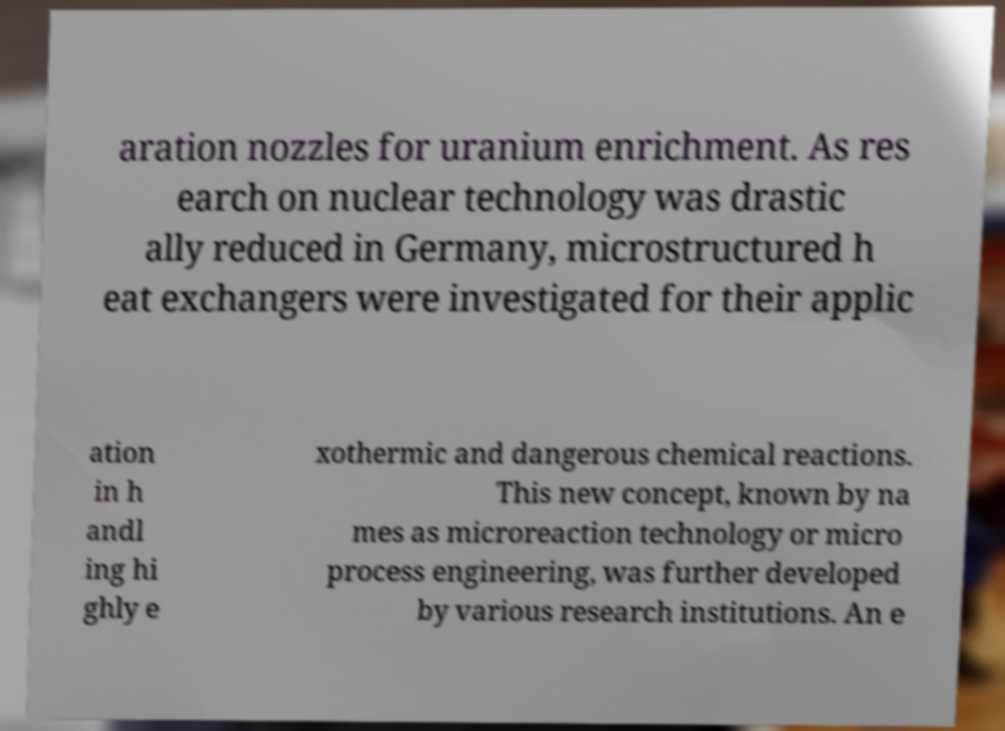Could you extract and type out the text from this image? aration nozzles for uranium enrichment. As res earch on nuclear technology was drastic ally reduced in Germany, microstructured h eat exchangers were investigated for their applic ation in h andl ing hi ghly e xothermic and dangerous chemical reactions. This new concept, known by na mes as microreaction technology or micro process engineering, was further developed by various research institutions. An e 